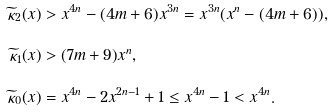<formula> <loc_0><loc_0><loc_500><loc_500>\widetilde { \kappa } _ { 2 } ( x ) & > x ^ { 4 n } - ( 4 m + 6 ) x ^ { 3 n } = x ^ { 3 n } ( x ^ { n } - ( 4 m + 6 ) ) , \\ \widetilde { \kappa } _ { 1 } ( x ) & > ( 7 m + 9 ) x ^ { n } , \\ \widetilde { \kappa } _ { 0 } ( x ) & = x ^ { 4 n } - 2 x ^ { 2 n - 1 } + 1 \leq x ^ { 4 n } - 1 < x ^ { 4 n } .</formula> 